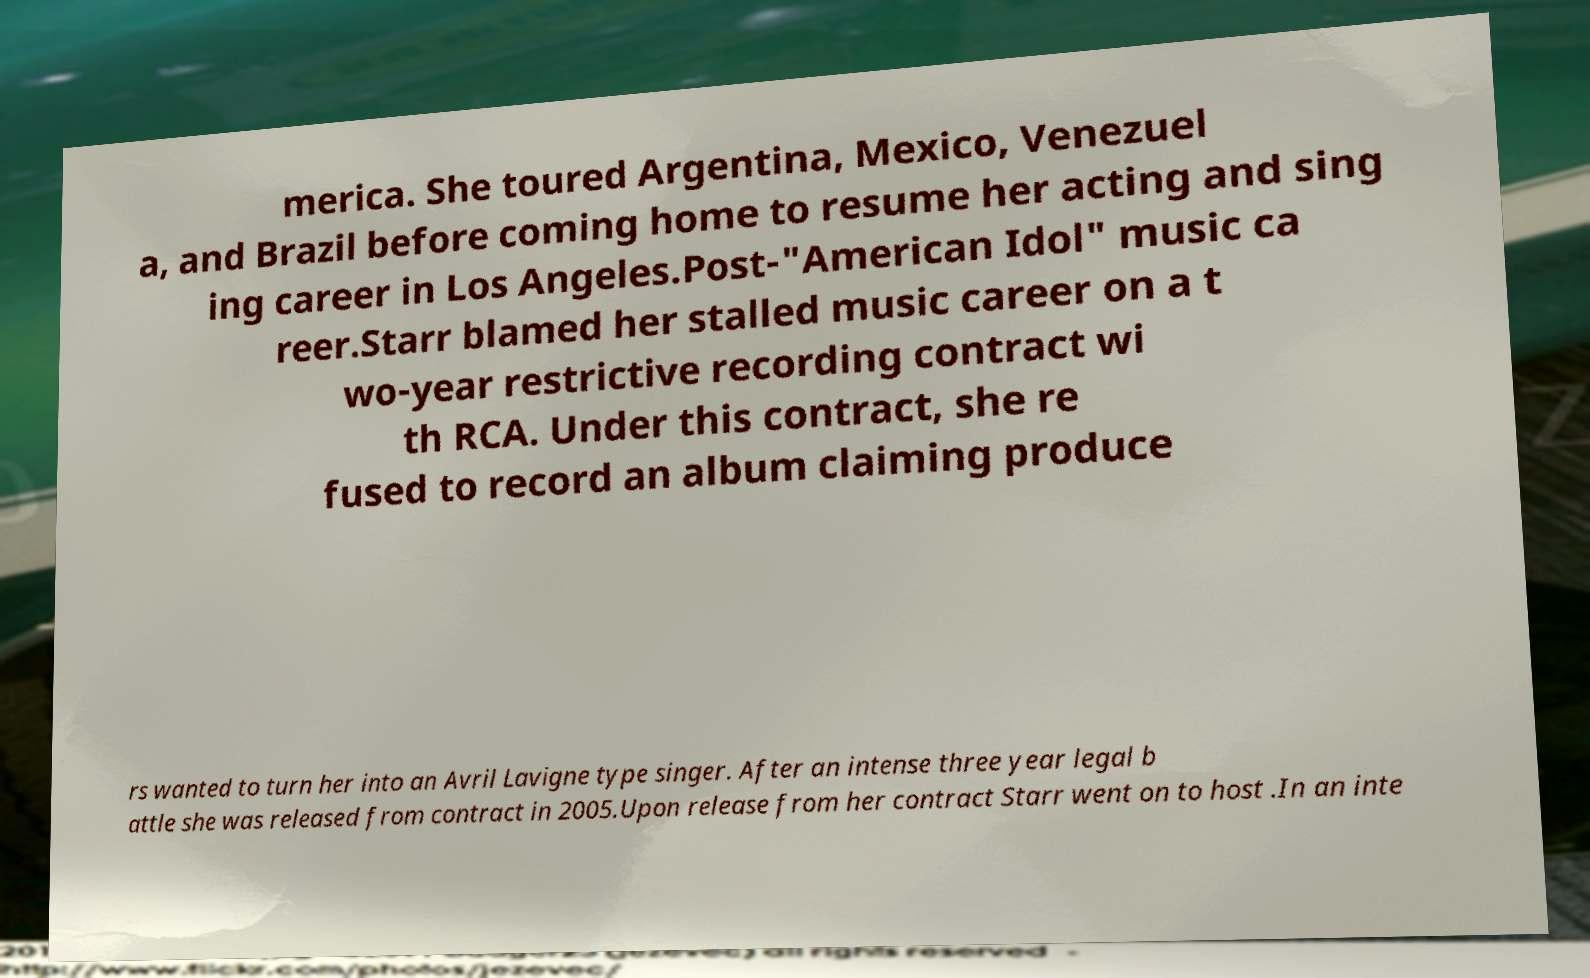What messages or text are displayed in this image? I need them in a readable, typed format. merica. She toured Argentina, Mexico, Venezuel a, and Brazil before coming home to resume her acting and sing ing career in Los Angeles.Post-"American Idol" music ca reer.Starr blamed her stalled music career on a t wo-year restrictive recording contract wi th RCA. Under this contract, she re fused to record an album claiming produce rs wanted to turn her into an Avril Lavigne type singer. After an intense three year legal b attle she was released from contract in 2005.Upon release from her contract Starr went on to host .In an inte 